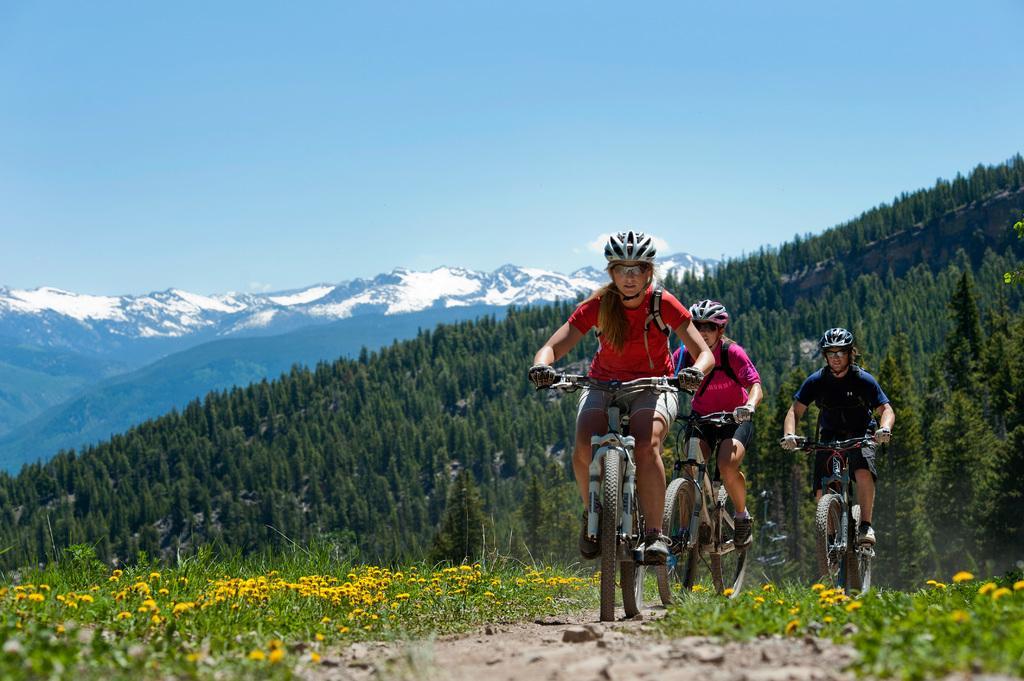How would you summarize this image in a sentence or two? In this picture there are three people riding bicycles and wore helmets and we can see flowers, plants and grass. In the background of the image we can see trees, mountain and sky. 